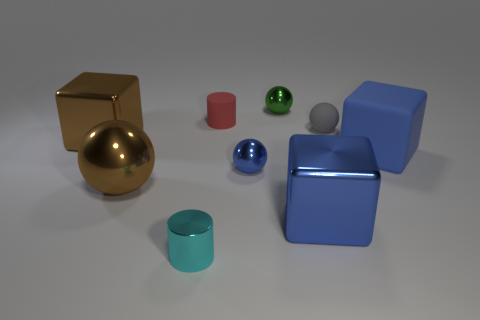Which objects in the image have the most reflective surfaces? The objects with the most reflective surfaces are the gold sphere and the shiny blue cube. Their surfaces are smooth and mirror-like, reflecting the environment and light around them vividly. 